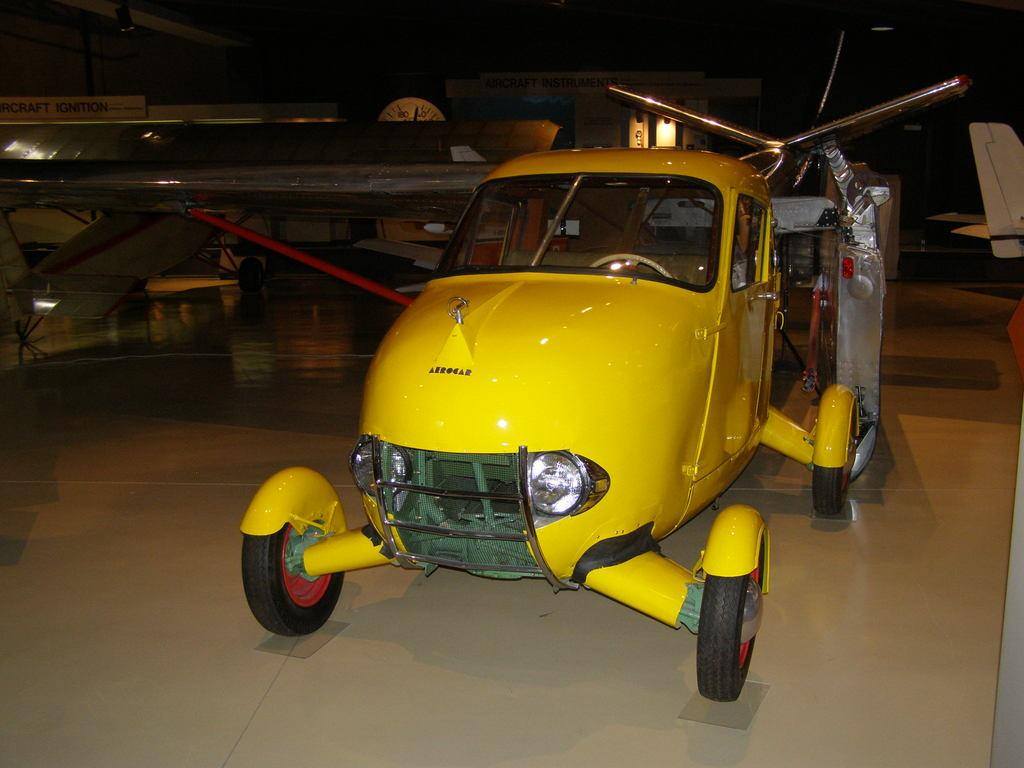What type of vehicles are in the image? There are helicopters in the image. What is the floor made of in the image? The floor is tiled in the image. What can be seen in the background of the image? There is a board, lights, and a clock in the background of the image. What type of wood is used to build the helicopters in the image? The helicopters in the image are not made of wood; they are likely made of metal and other materials. 